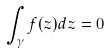<formula> <loc_0><loc_0><loc_500><loc_500>\int _ { \gamma } f ( z ) d z = 0</formula> 